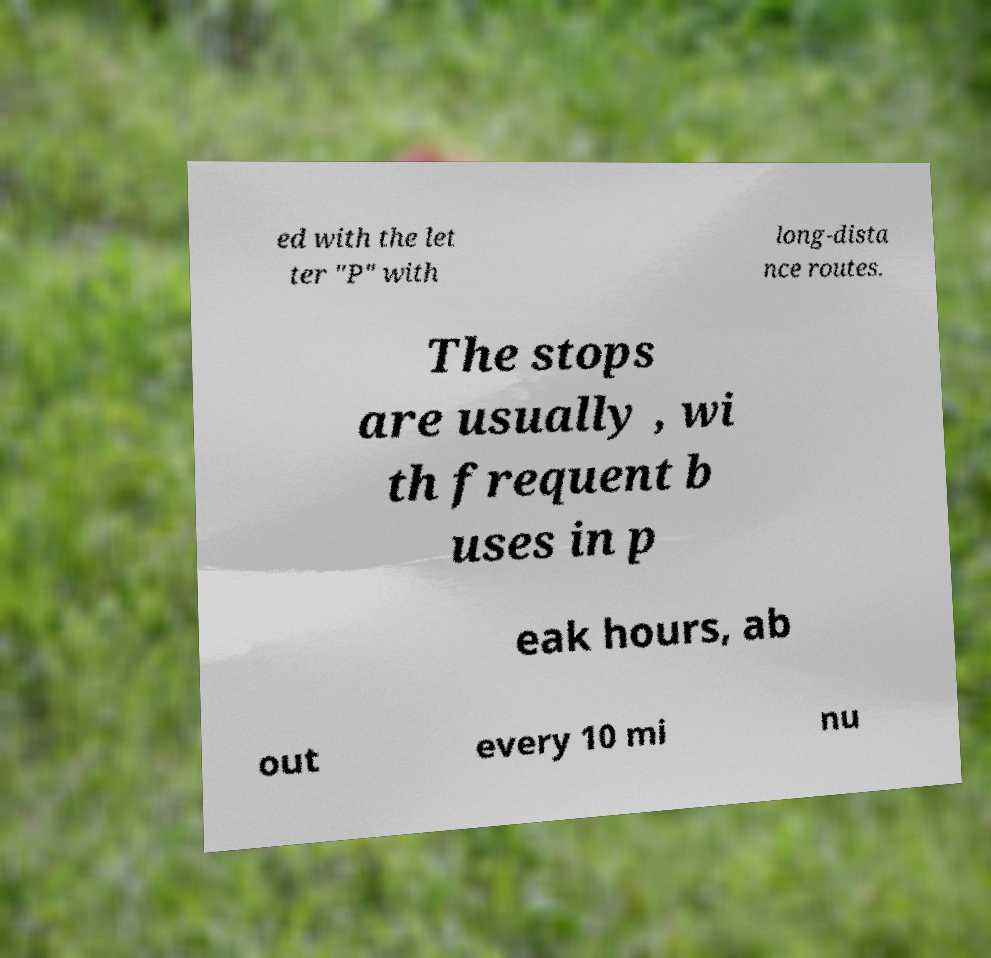For documentation purposes, I need the text within this image transcribed. Could you provide that? ed with the let ter "P" with long-dista nce routes. The stops are usually , wi th frequent b uses in p eak hours, ab out every 10 mi nu 